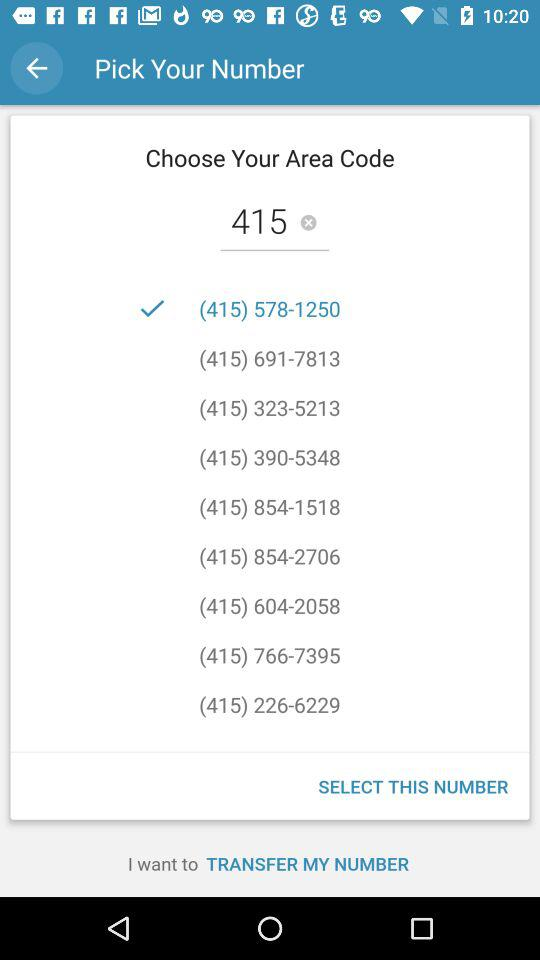Which is the selected number? The selected number is (415) 578-1250. 